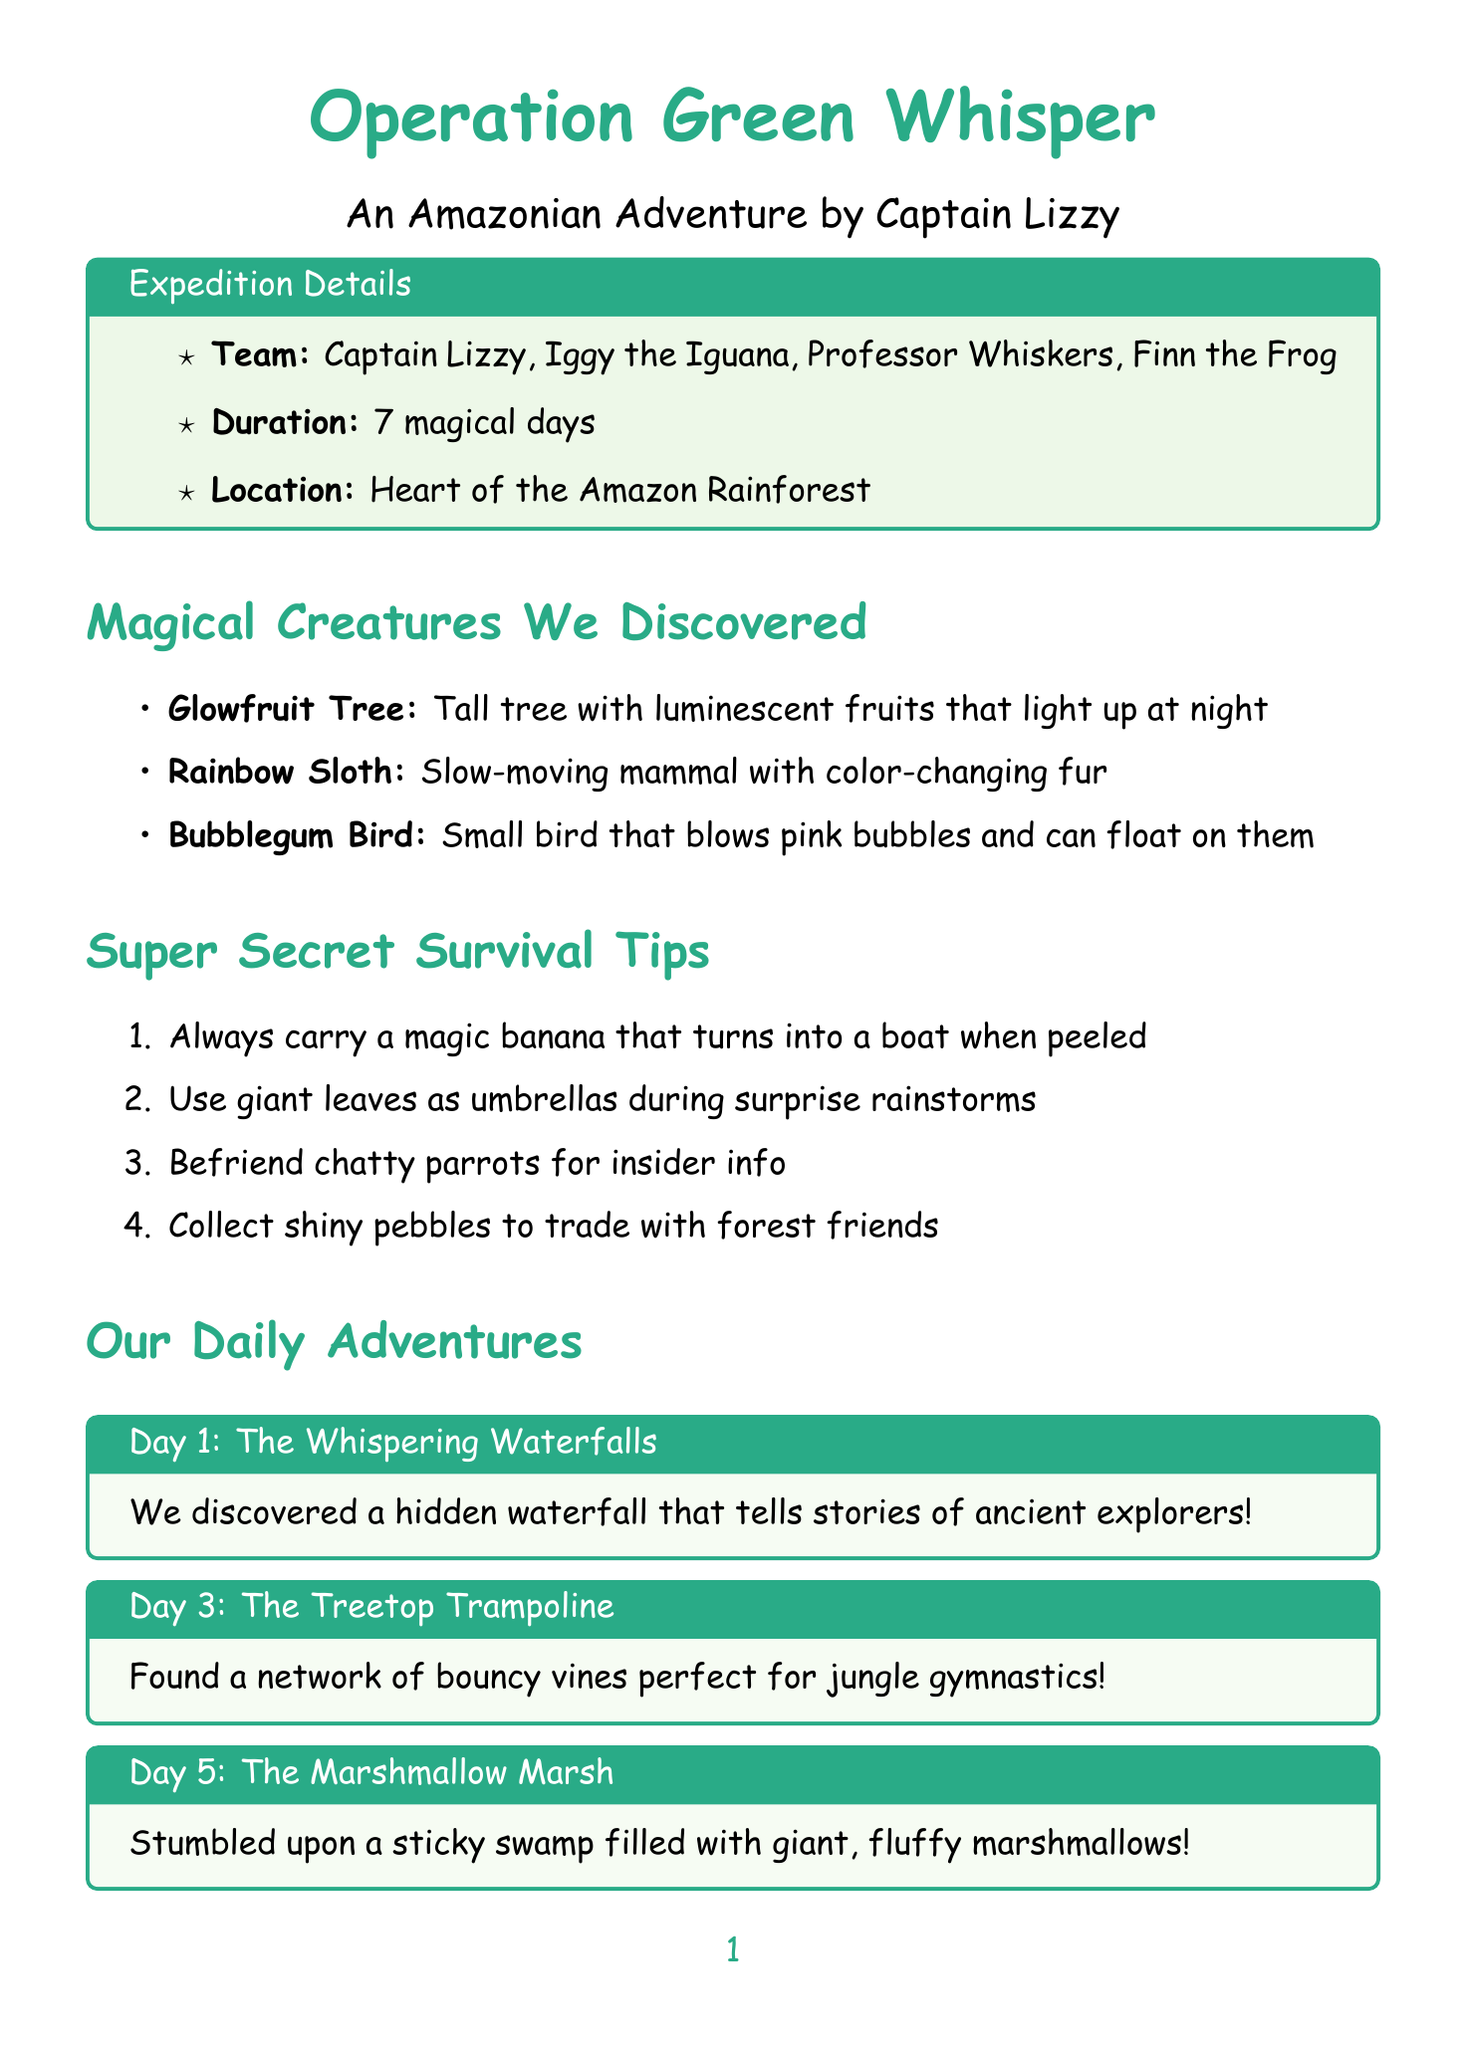What is the name of the expedition? The name of the expedition is mentioned in the document and is 'Operation Green Whisper'.
Answer: Operation Green Whisper Who is the team's expert jumper? The document lists team members, and Finn the Frog is labeled as the expert jumper.
Answer: Finn the Frog How many days did the expedition last? The document specifies that the duration of the expedition was 7 magical days.
Answer: 7 magical days What unusual tree was discovered during the expedition? The document includes invented species, and the 'Glowfruit Tree' is one of them.
Answer: Glowfruit Tree What is one of the survival tips mentioned? The document lists survival tips, such as "Always carry a magic banana that turns into a boat when you peel it."
Answer: Always carry a magic banana What challenge involved wise old toucans? The document mentions a challenge related to solving riddles posed by wise old toucans.
Answer: Solving riddles posed by wise old toucans What did the team find on Day 5? The document details the daily adventures, and on Day 5, they stumbled upon the 'Marshmallow Marsh'.
Answer: The Marshmallow Marsh What is the next adventure planned? The conclusion of the document states the future plans to explore the 'mysterious Upside-Down Caves'.
Answer: The mysterious Upside-Down Caves 